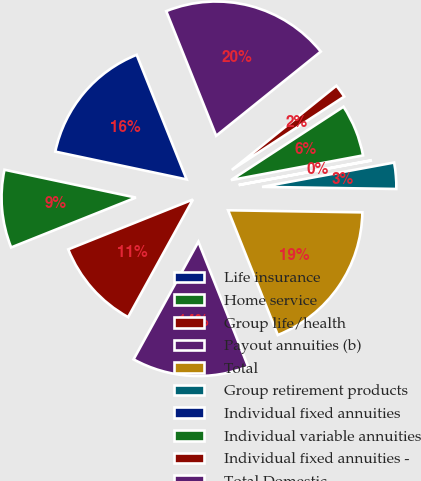Convert chart. <chart><loc_0><loc_0><loc_500><loc_500><pie_chart><fcel>Life insurance<fcel>Home service<fcel>Group life/health<fcel>Payout annuities (b)<fcel>Total<fcel>Group retirement products<fcel>Individual fixed annuities<fcel>Individual variable annuities<fcel>Individual fixed annuities -<fcel>Total Domestic<nl><fcel>15.61%<fcel>9.38%<fcel>10.93%<fcel>14.05%<fcel>18.72%<fcel>3.15%<fcel>0.04%<fcel>6.26%<fcel>1.59%<fcel>20.28%<nl></chart> 